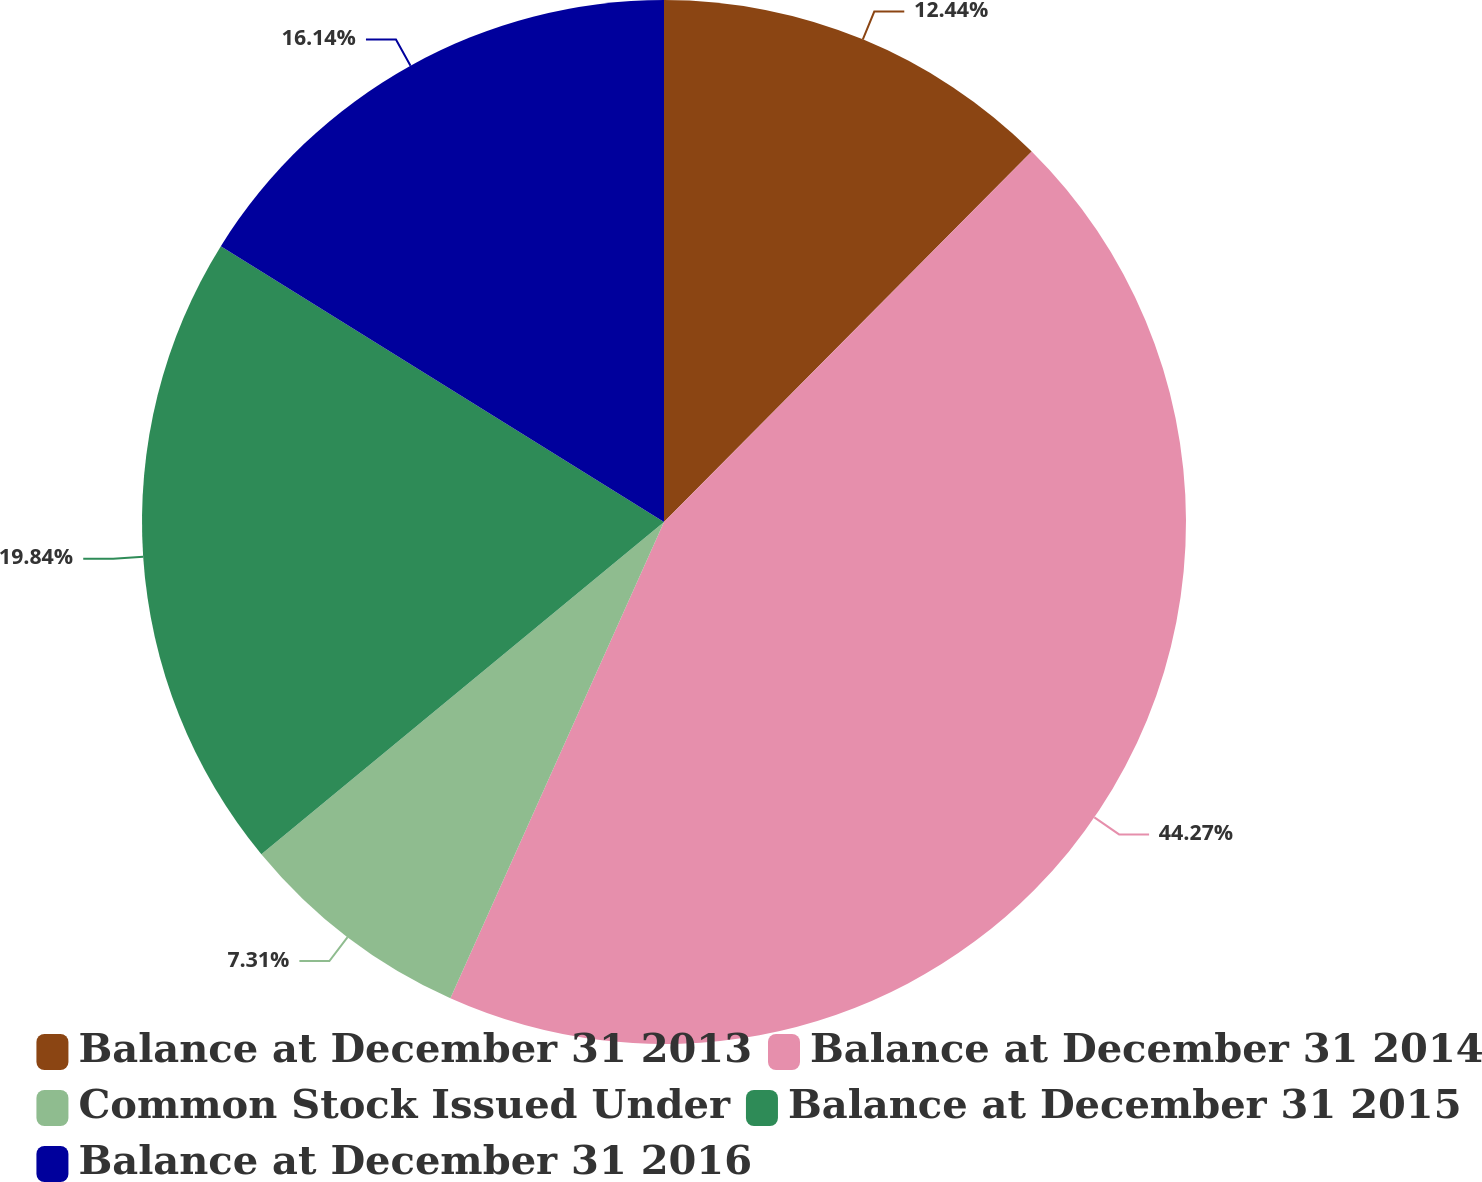<chart> <loc_0><loc_0><loc_500><loc_500><pie_chart><fcel>Balance at December 31 2013<fcel>Balance at December 31 2014<fcel>Common Stock Issued Under<fcel>Balance at December 31 2015<fcel>Balance at December 31 2016<nl><fcel>12.44%<fcel>44.27%<fcel>7.31%<fcel>19.84%<fcel>16.14%<nl></chart> 